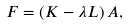<formula> <loc_0><loc_0><loc_500><loc_500>F = \left ( K - \lambda L \right ) A ,</formula> 